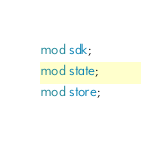<code> <loc_0><loc_0><loc_500><loc_500><_Rust_>mod sdk;
mod state;
mod store;
</code> 